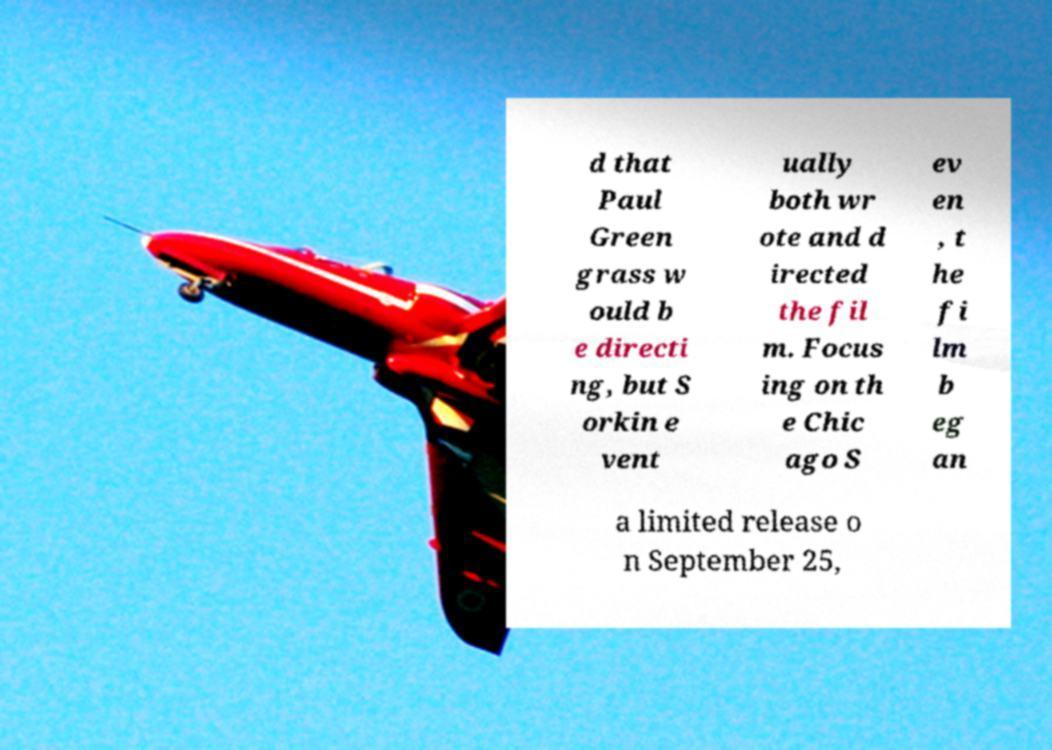What messages or text are displayed in this image? I need them in a readable, typed format. d that Paul Green grass w ould b e directi ng, but S orkin e vent ually both wr ote and d irected the fil m. Focus ing on th e Chic ago S ev en , t he fi lm b eg an a limited release o n September 25, 